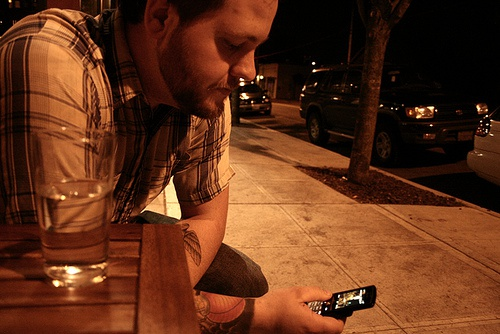Describe the objects in this image and their specific colors. I can see people in black, maroon, brown, and orange tones, dining table in black, maroon, and brown tones, truck in black, maroon, brown, and orange tones, cup in black, maroon, and brown tones, and car in black, maroon, and brown tones in this image. 